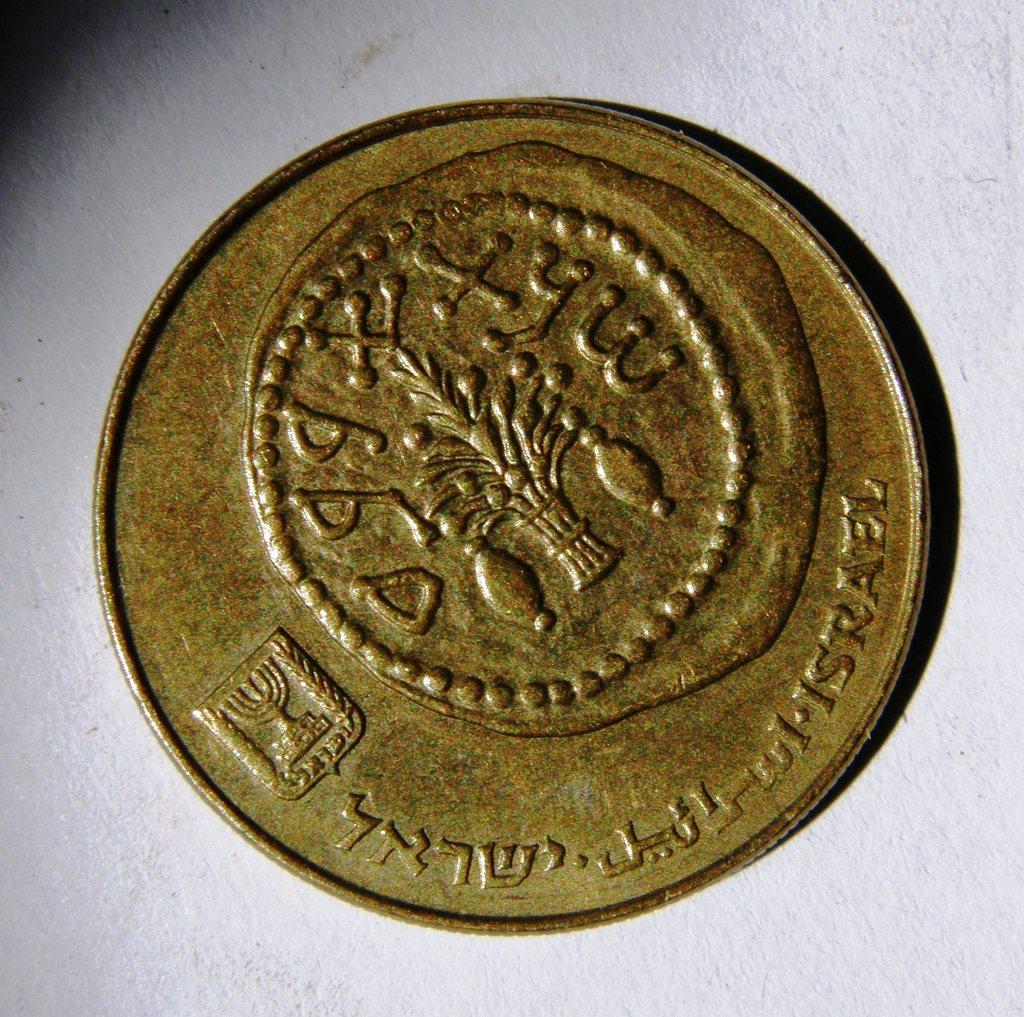<image>
Provide a brief description of the given image. An ancient, bronze colored coin with Hebrew writing and the word Israel etched into it. 